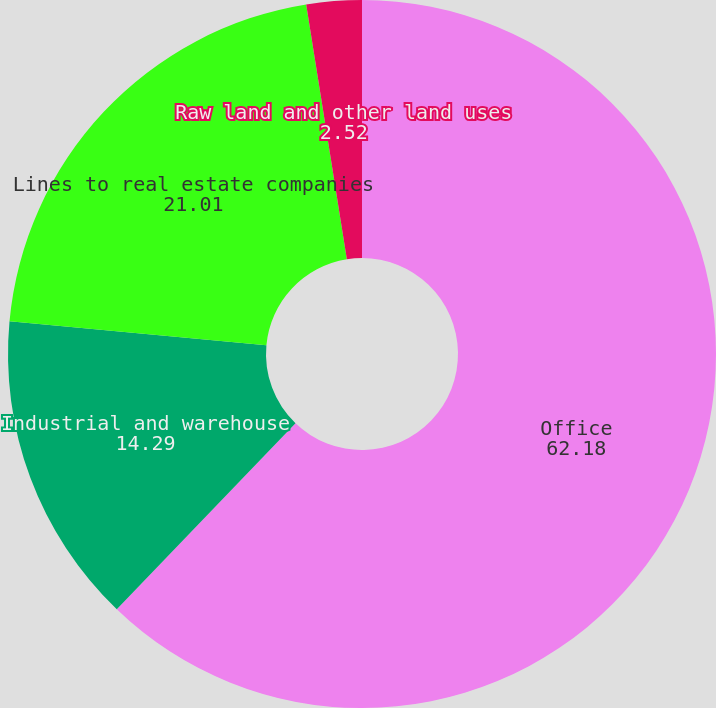Convert chart to OTSL. <chart><loc_0><loc_0><loc_500><loc_500><pie_chart><fcel>Office<fcel>Industrial and warehouse<fcel>Lines to real estate companies<fcel>Raw land and other land uses<nl><fcel>62.18%<fcel>14.29%<fcel>21.01%<fcel>2.52%<nl></chart> 